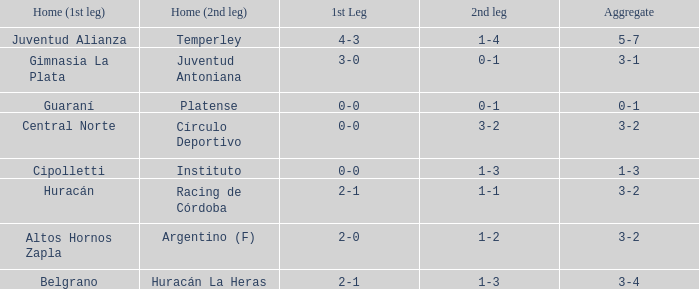What was the score of the 2nd leg when the Belgrano played the first leg at home with a score of 2-1? 1-3. 